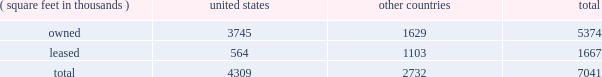Item 2 : properties information concerning applied 2019s properties at october 30 , 2016 is set forth below: .
Because of the interrelation of applied 2019s operations , properties within a country may be shared by the segments operating within that country .
The company 2019s headquarters offices are in santa clara , california .
Products in semiconductor systems are manufactured in austin , texas ; gloucester , massachusetts ; kalispell , montana ; rehovot , israel ; and singapore .
Remanufactured equipment products in the applied global services segment are produced primarily in austin , texas .
Products in the display and adjacent markets segment are manufactured in alzenau , germany ; tainan , taiwan ; and santa clara , california .
Other products are manufactured in treviso , italy .
Applied also owns and leases offices , plants and warehouse locations in many locations throughout the world , including in europe , japan , north america ( principally the united states ) , israel , china , india , korea , southeast asia and taiwan .
These facilities are principally used for manufacturing ; research , development and engineering ; and marketing , sales and customer support .
Applied also owns a total of approximately 280 acres of buildable land in montana , texas , california , massachusetts , israel and italy that could accommodate additional building space .
Applied considers the properties that it owns or leases as adequate to meet its current and future requirements .
Applied regularly assesses the size , capability and location of its global infrastructure and periodically makes adjustments based on these assessments. .
What was the total amount of land owned by the company ? ( 1 acre = 43560 square feet )? 
Rationale: the total square feet owned by the company includes the acres owned by the company . therefore you have to take the total amount of square feet owned of property and added the total amount of acres .
Computations: ((280 * 43560) + (7041 * 1000))
Answer: 19237800.0. 